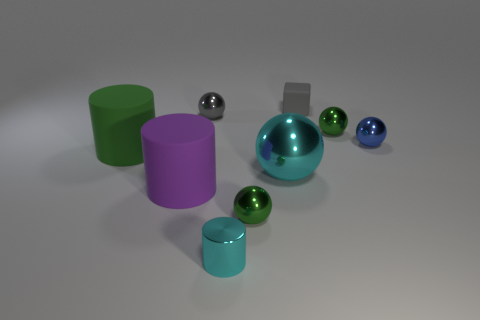Subtract all big spheres. How many spheres are left? 4 Subtract 2 balls. How many balls are left? 3 Subtract all cyan balls. How many balls are left? 4 Subtract all brown balls. Subtract all green cylinders. How many balls are left? 5 Subtract all balls. How many objects are left? 4 Add 5 big purple cylinders. How many big purple cylinders exist? 6 Subtract 1 cyan cylinders. How many objects are left? 8 Subtract all large cylinders. Subtract all tiny metal cylinders. How many objects are left? 6 Add 5 big cylinders. How many big cylinders are left? 7 